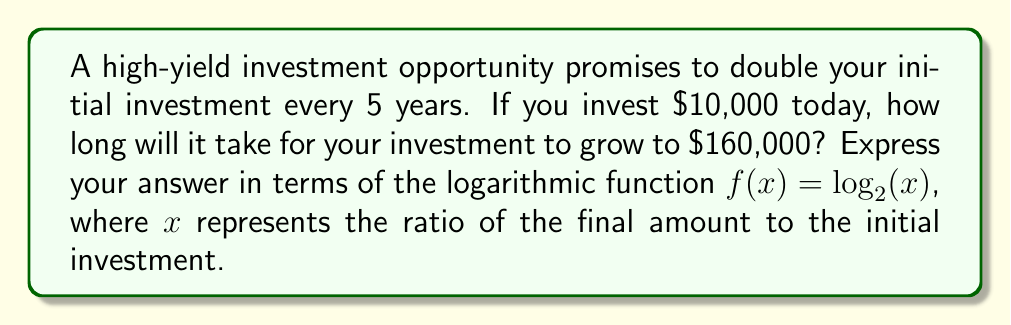Teach me how to tackle this problem. Let's approach this step-by-step:

1) First, we need to determine the ratio of the final amount to the initial investment:
   $\frac{\text{Final Amount}}{\text{Initial Investment}} = \frac{160,000}{10,000} = 16$

2) We know that the investment doubles every 5 years. This can be represented as:
   $2^n = 16$, where $n$ is the number of 5-year periods.

3) To solve this, we can use the logarithm base 2:
   $\log_2(2^n) = \log_2(16)$

4) Using the logarithm property $\log_a(a^x) = x$, we get:
   $n = \log_2(16)$

5) Now, let's define our function $f(x) = \log_2(x)$. In this case, $x = 16$.

6) So, $n = f(16) = \log_2(16) = 4$

7) Since $n$ represents the number of 5-year periods, we multiply by 5 to get the total number of years:
   $\text{Years} = 5n = 5f(16) = 5\log_2(16) = 20$

Thus, it will take 20 years for the investment to grow from $10,000 to $160,000.
Answer: $5f(16) = 20$ years 